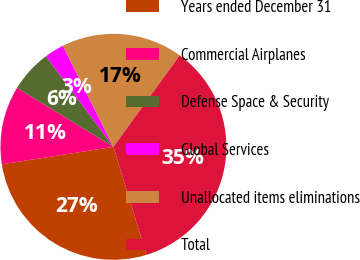Convert chart to OTSL. <chart><loc_0><loc_0><loc_500><loc_500><pie_chart><fcel>Years ended December 31<fcel>Commercial Airplanes<fcel>Defense Space & Security<fcel>Global Services<fcel>Unallocated items eliminations<fcel>Total<nl><fcel>27.24%<fcel>11.21%<fcel>6.07%<fcel>2.82%<fcel>17.35%<fcel>35.3%<nl></chart> 